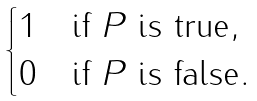<formula> <loc_0><loc_0><loc_500><loc_500>\begin{cases} 1 & \text {if $P$ is true} , \\ 0 & \text {if $P$ is false} . \end{cases}</formula> 